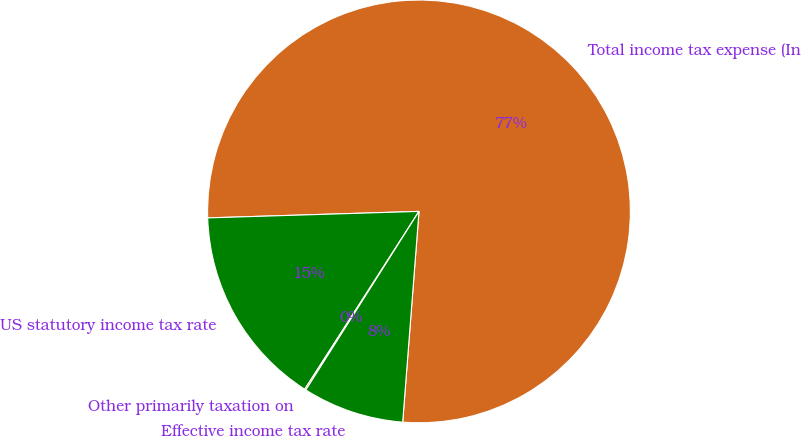Convert chart. <chart><loc_0><loc_0><loc_500><loc_500><pie_chart><fcel>Total income tax expense (In<fcel>US statutory income tax rate<fcel>Other primarily taxation on<fcel>Effective income tax rate<nl><fcel>76.71%<fcel>15.42%<fcel>0.1%<fcel>7.76%<nl></chart> 